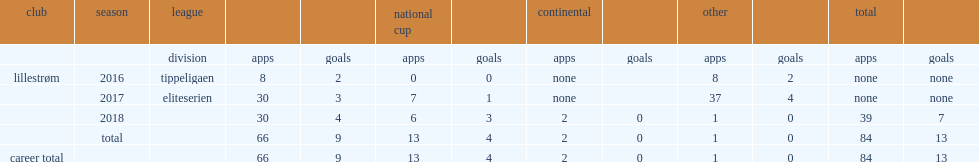Which club did mathew play for in 2016? Lillestrøm. 